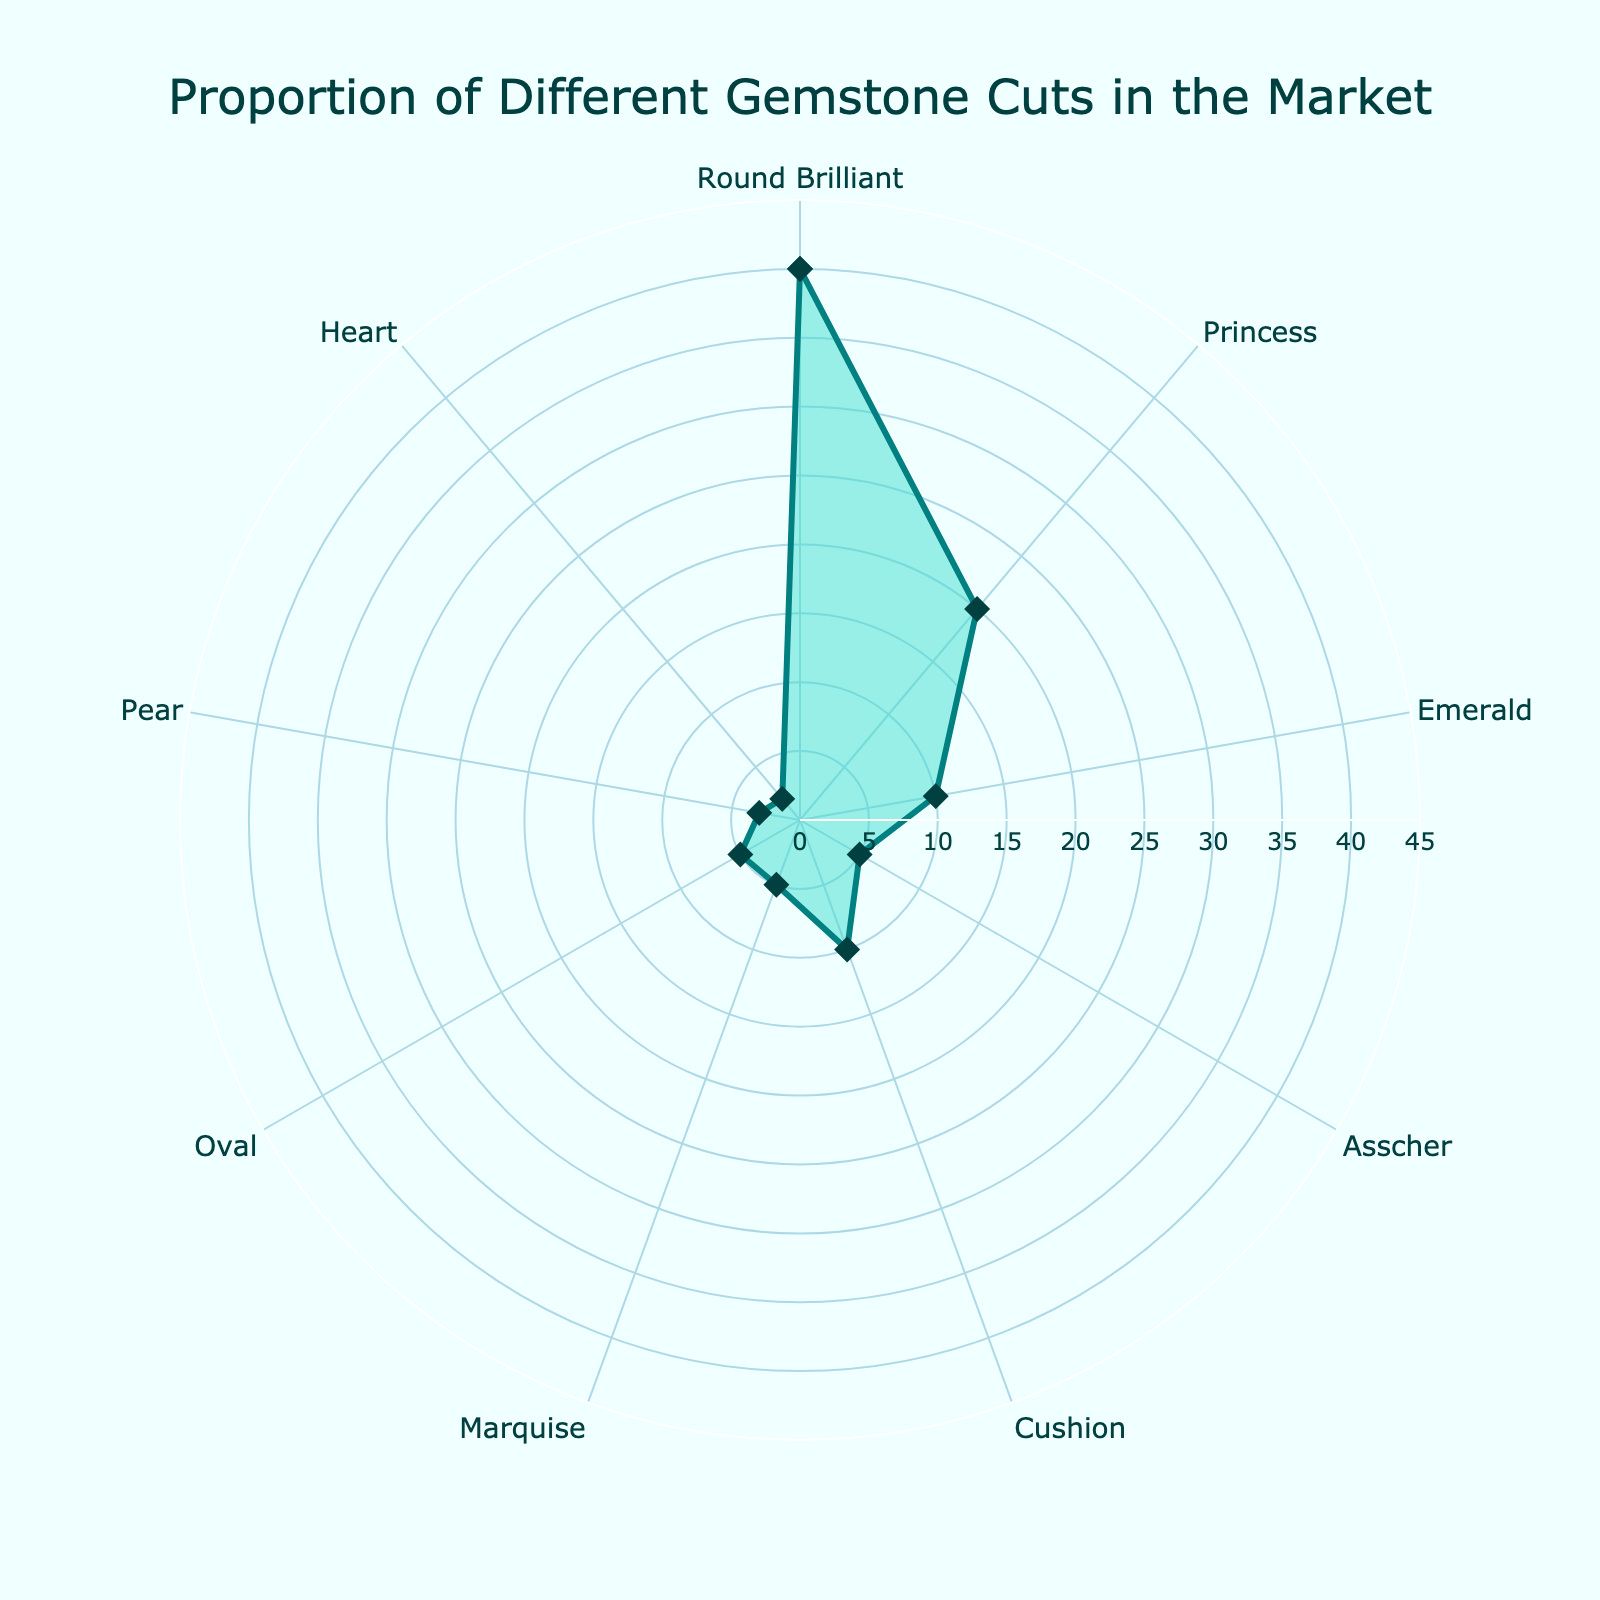What's the title of the chart? The title is located at the top of the chart and provides the main topic of the figure.
Answer: Proportion of Different Gemstone Cuts in the Market What is the highest percentage cut shown on the chart? By looking at the values on the radar chart, we find the longest line from the center which represents the highest value.
Answer: Round Brilliant How many different gemstone cuts are presented in the chart? We count the number of distinct categories around the radar chart.
Answer: 9 What's the combined proportion of the Princess and Cushion cuts? By adding the percentages of the Princess (20) and Cushion (10) cuts. 20 + 10 = 30
Answer: 30 Which cut has a smaller market proportion, Pear or Heart? We compare the market proportions given for Pear (3) and Heart (2) cuts.
Answer: Heart What is the difference in market share between the Round Brilliant cut and the Asscher cut? Subtracting the percentage of the Asscher cut (5) from the Round Brilliant cut (40). 40 - 5 = 35
Answer: 35 If the market share of Oval cut were to double, what would its new percentage be? Doubling the current percentage of Oval cut (5), 5 * 2 = 10
Answer: 10 Which cuts have a market share of 5%? By identifying the cuts in the chart that align with the 5% value.
Answer: Asscher, Marquise, and Oval What is the average market proportion of the Emerald and Marquise cuts? Adding the percentages of Emerald (10) and Marquise (5) and then dividing by 2. (10 + 5) / 2 = 7.5
Answer: 7.5 What's the least represented cut in the market, according to the chart? Looking for the smallest percentage value in the radar chart.
Answer: Heart 